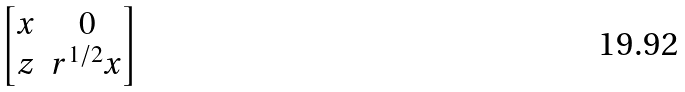<formula> <loc_0><loc_0><loc_500><loc_500>\begin{bmatrix} x & 0 \\ z & r ^ { 1 / 2 } x \end{bmatrix}</formula> 